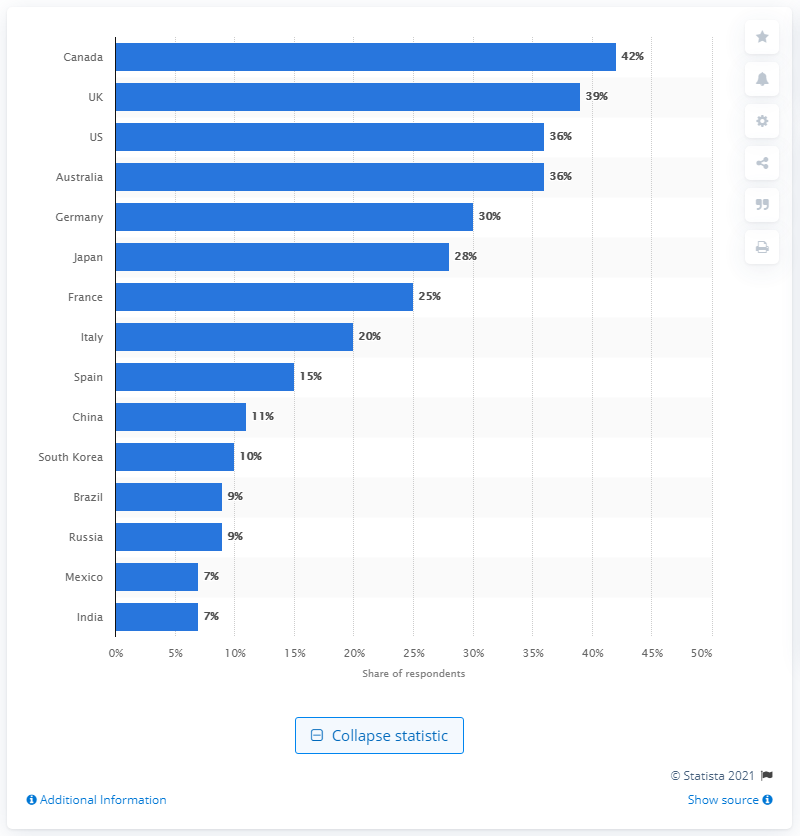Outline some significant characteristics in this image. In 2016, Canada had one of the best reputations worldwide. A total of 39% of respondents rated the UK as the second most attractive country in both trustworthiness and making new friends. 